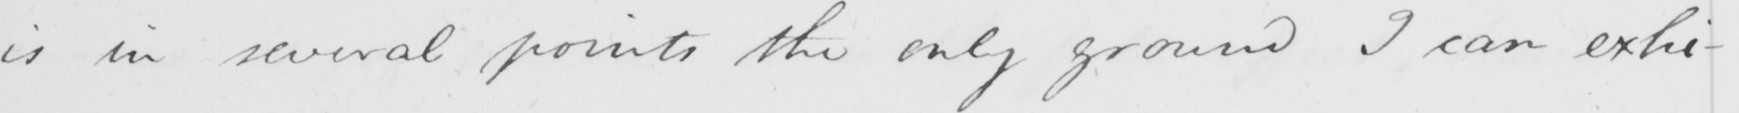Transcribe the text shown in this historical manuscript line. is in several points the only ground I can exhi- 